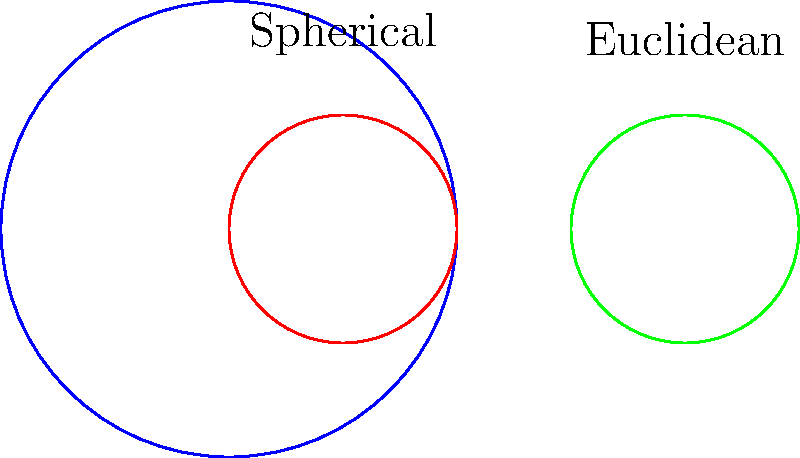Consider a circle with radius $r$ on a sphere of radius $R$, where $r < R$. How does the area of this circle compare to the area of a Euclidean circle with the same radius $r$? Assume $r = 0.5R$. Let's approach this step-by-step:

1) First, recall the formula for the area of a circle on a sphere (also known as a spherical cap):
   $$A_{sphere} = 2\pi R^2(1 - \cos(\theta))$$
   where $\theta$ is the angle subtended at the center of the sphere.

2) We can relate $r$ and $R$ to $\theta$ using:
   $$r = R \sin(\theta)$$

3) Given $r = 0.5R$, we can find $\theta$:
   $$0.5R = R \sin(\theta)$$
   $$0.5 = \sin(\theta)$$
   $$\theta = \arcsin(0.5) \approx 0.5236 \text{ radians}$$

4) Now we can calculate $\cos(\theta)$:
   $$\cos(\theta) = \sqrt{1 - \sin^2(\theta)} = \sqrt{1 - 0.5^2} = \frac{\sqrt{3}}{2}$$

5) Substituting into the spherical cap area formula:
   $$A_{sphere} = 2\pi R^2(1 - \frac{\sqrt{3}}{2}) \approx 0.8418\pi R^2$$

6) The area of a Euclidean circle with radius $r = 0.5R$ is:
   $$A_{euclidean} = \pi r^2 = \pi (0.5R)^2 = 0.25\pi R^2$$

7) The ratio of the spherical area to the Euclidean area is:
   $$\frac{A_{sphere}}{A_{euclidean}} = \frac{0.8418\pi R^2}{0.25\pi R^2} \approx 3.3672$$

Therefore, the area of the circle on the spherical surface is approximately 3.3672 times larger than its Euclidean counterpart.
Answer: 3.3672 times larger 